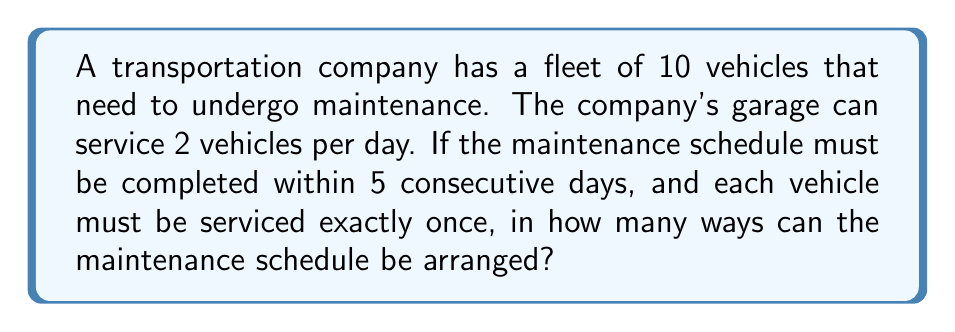Teach me how to tackle this problem. Let's approach this step-by-step:

1) First, we need to understand that this is a problem of distributing 10 distinct objects (vehicles) into 5 distinct groups (days), where each group must contain exactly 2 objects.

2) This type of problem can be solved using the concept of multinomial coefficients.

3) The formula for multinomial coefficients is:

   $$\binom{n}{n_1, n_2, ..., n_k} = \frac{n!}{n_1! \cdot n_2! \cdot ... \cdot n_k!}$$

   where $n$ is the total number of objects, and $n_1, n_2, ..., n_k$ are the number of objects in each group.

4) In our case:
   $n = 10$ (total vehicles)
   $n_1 = n_2 = n_3 = n_4 = n_5 = 2$ (2 vehicles per day for 5 days)

5) Plugging these values into the formula:

   $$\binom{10}{2, 2, 2, 2, 2} = \frac{10!}{2! \cdot 2! \cdot 2! \cdot 2! \cdot 2!}$$

6) Simplify:
   $$\frac{10!}{(2!)^5} = \frac{10 \cdot 9 \cdot 8 \cdot 7 \cdot 6 \cdot 5!}{2 \cdot 2 \cdot 2 \cdot 2 \cdot 2}$$

7) Calculate:
   $$\frac{3,628,800}{32} = 113,400$$

Therefore, there are 113,400 ways to arrange the maintenance schedule.
Answer: 113,400 